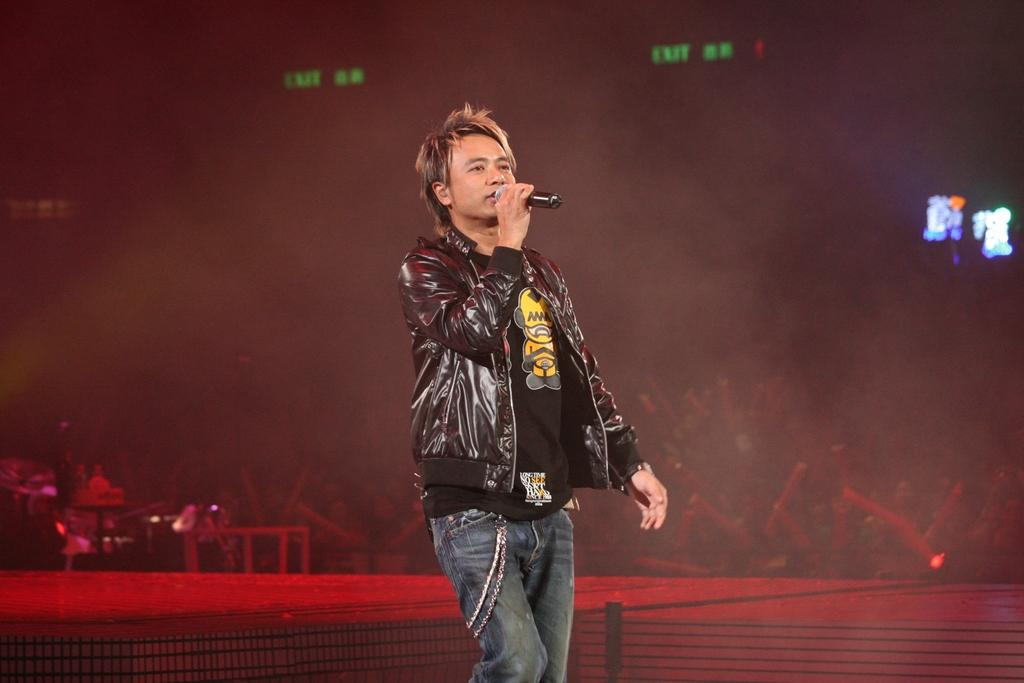Who is the main subject in the image? There is a man in the image. What is the man doing in the image? The man is in motion. What is the man wearing in the image? The man is wearing a black jacket. What object is the man holding in the image? The man is holding a microphone. What can be observed about the background of the image? The background of the image is dark. What type of humor can be seen in the man's facial expression in the image? There is no indication of humor or facial expression in the image; it only shows a man in motion, wearing a black jacket, and holding a microphone. 